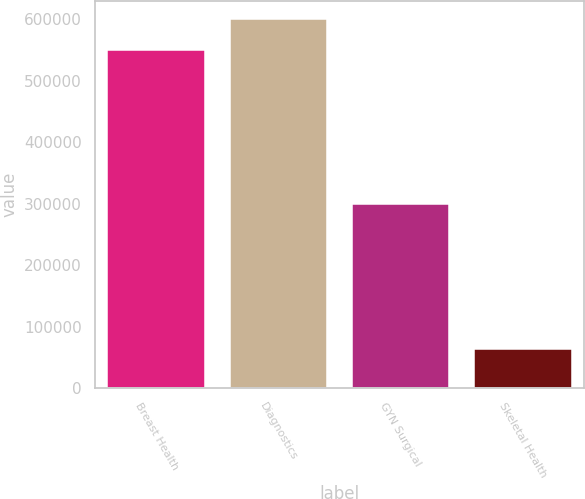Convert chart. <chart><loc_0><loc_0><loc_500><loc_500><bar_chart><fcel>Breast Health<fcel>Diagnostics<fcel>GYN Surgical<fcel>Skeletal Health<nl><fcel>550112<fcel>600471<fcel>299120<fcel>62759<nl></chart> 